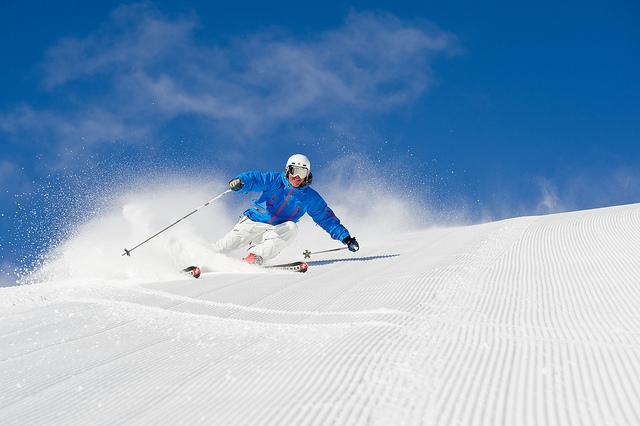Is it cold where this person is?
Answer briefly. Yes. How many skies are off the ground?
Keep it brief. 0. What color coat is he wearing?
Concise answer only. Blue. Is the sky clear?
Short answer required. Yes. Has the ski slope been groomed?
Quick response, please. Yes. 